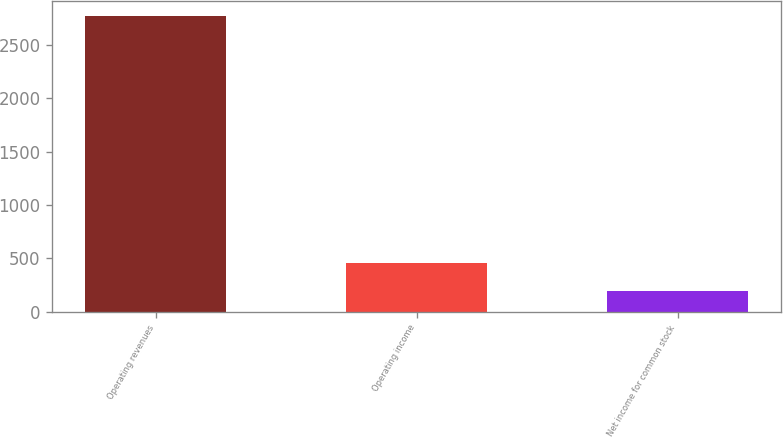Convert chart. <chart><loc_0><loc_0><loc_500><loc_500><bar_chart><fcel>Operating revenues<fcel>Operating income<fcel>Net income for common stock<nl><fcel>2770<fcel>454.3<fcel>197<nl></chart> 